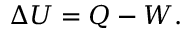<formula> <loc_0><loc_0><loc_500><loc_500>\Delta U = Q - W .</formula> 